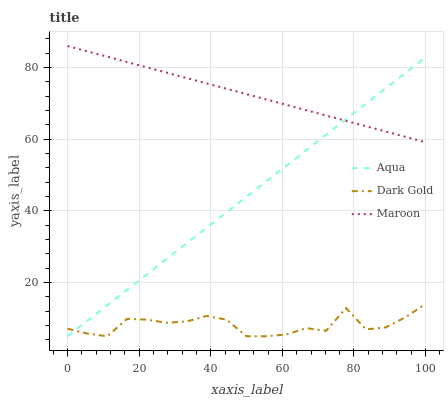Does Dark Gold have the minimum area under the curve?
Answer yes or no. Yes. Does Maroon have the maximum area under the curve?
Answer yes or no. Yes. Does Maroon have the minimum area under the curve?
Answer yes or no. No. Does Dark Gold have the maximum area under the curve?
Answer yes or no. No. Is Maroon the smoothest?
Answer yes or no. Yes. Is Dark Gold the roughest?
Answer yes or no. Yes. Is Dark Gold the smoothest?
Answer yes or no. No. Is Maroon the roughest?
Answer yes or no. No. Does Aqua have the lowest value?
Answer yes or no. Yes. Does Maroon have the lowest value?
Answer yes or no. No. Does Maroon have the highest value?
Answer yes or no. Yes. Does Dark Gold have the highest value?
Answer yes or no. No. Is Dark Gold less than Maroon?
Answer yes or no. Yes. Is Maroon greater than Dark Gold?
Answer yes or no. Yes. Does Maroon intersect Aqua?
Answer yes or no. Yes. Is Maroon less than Aqua?
Answer yes or no. No. Is Maroon greater than Aqua?
Answer yes or no. No. Does Dark Gold intersect Maroon?
Answer yes or no. No. 